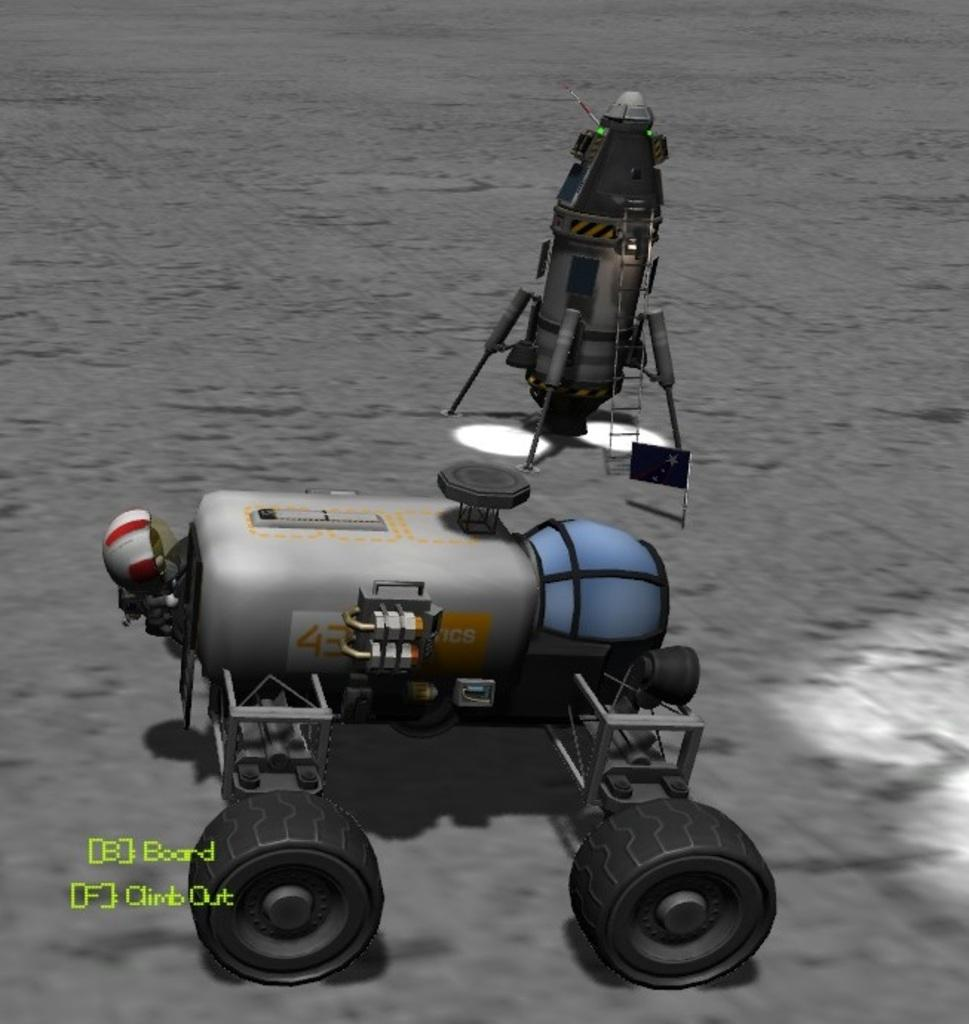<image>
Summarize the visual content of the image. A screen shot from a video game shows a robot on a desolate planet with the options of Board or Climb Out. 